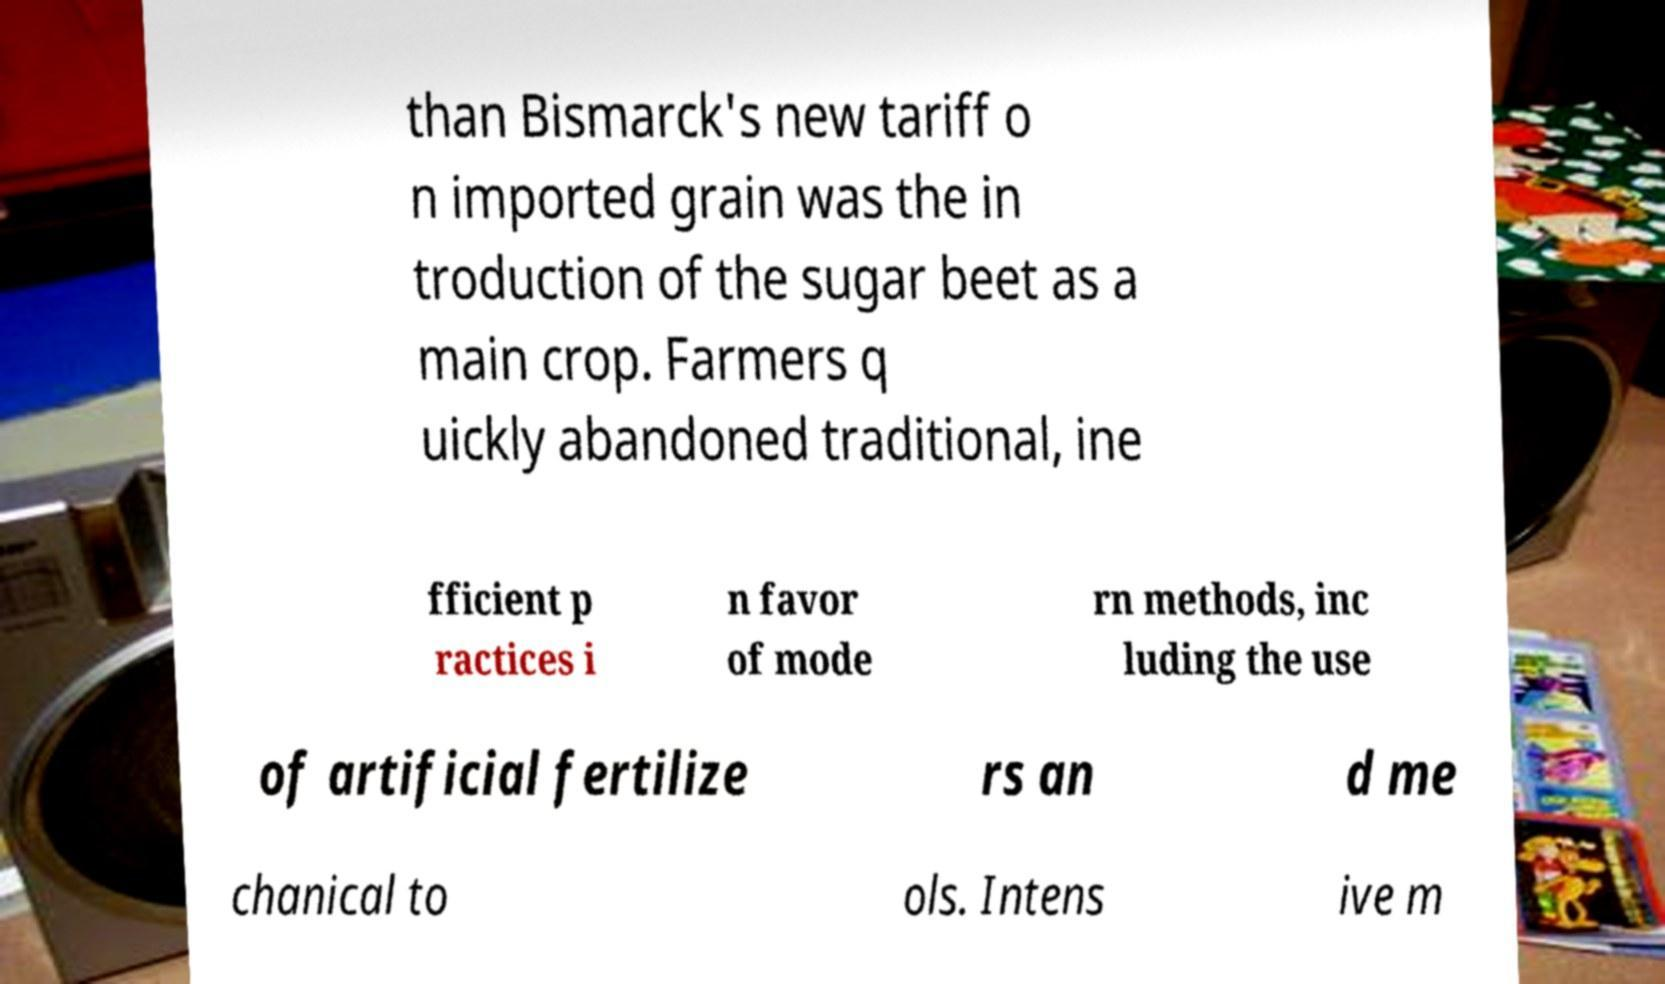There's text embedded in this image that I need extracted. Can you transcribe it verbatim? than Bismarck's new tariff o n imported grain was the in troduction of the sugar beet as a main crop. Farmers q uickly abandoned traditional, ine fficient p ractices i n favor of mode rn methods, inc luding the use of artificial fertilize rs an d me chanical to ols. Intens ive m 